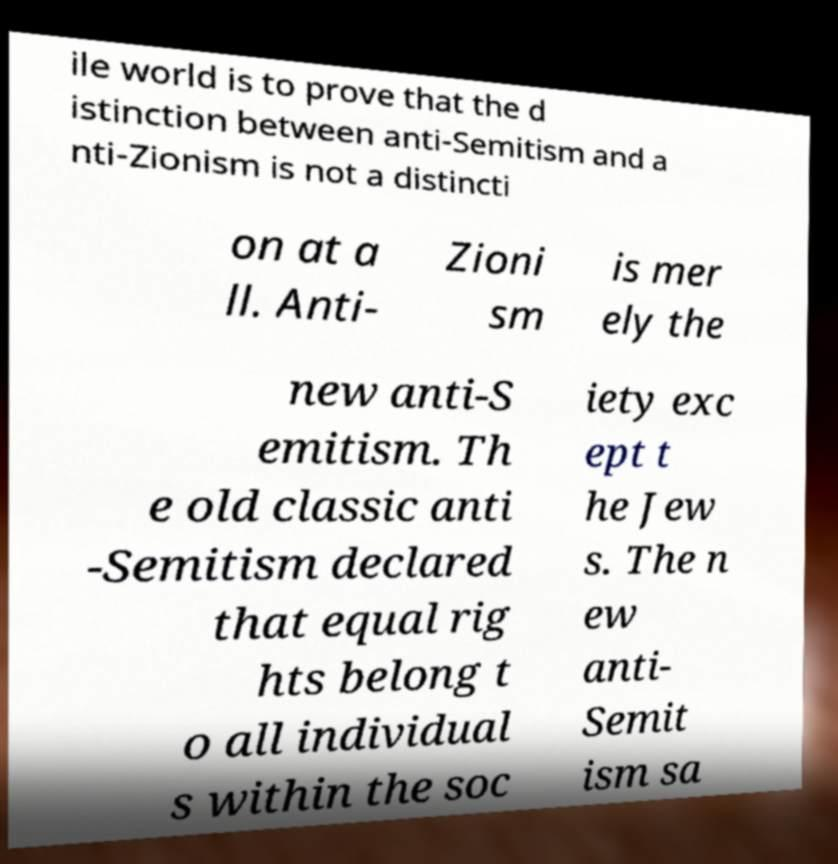For documentation purposes, I need the text within this image transcribed. Could you provide that? ile world is to prove that the d istinction between anti-Semitism and a nti-Zionism is not a distincti on at a ll. Anti- Zioni sm is mer ely the new anti-S emitism. Th e old classic anti -Semitism declared that equal rig hts belong t o all individual s within the soc iety exc ept t he Jew s. The n ew anti- Semit ism sa 